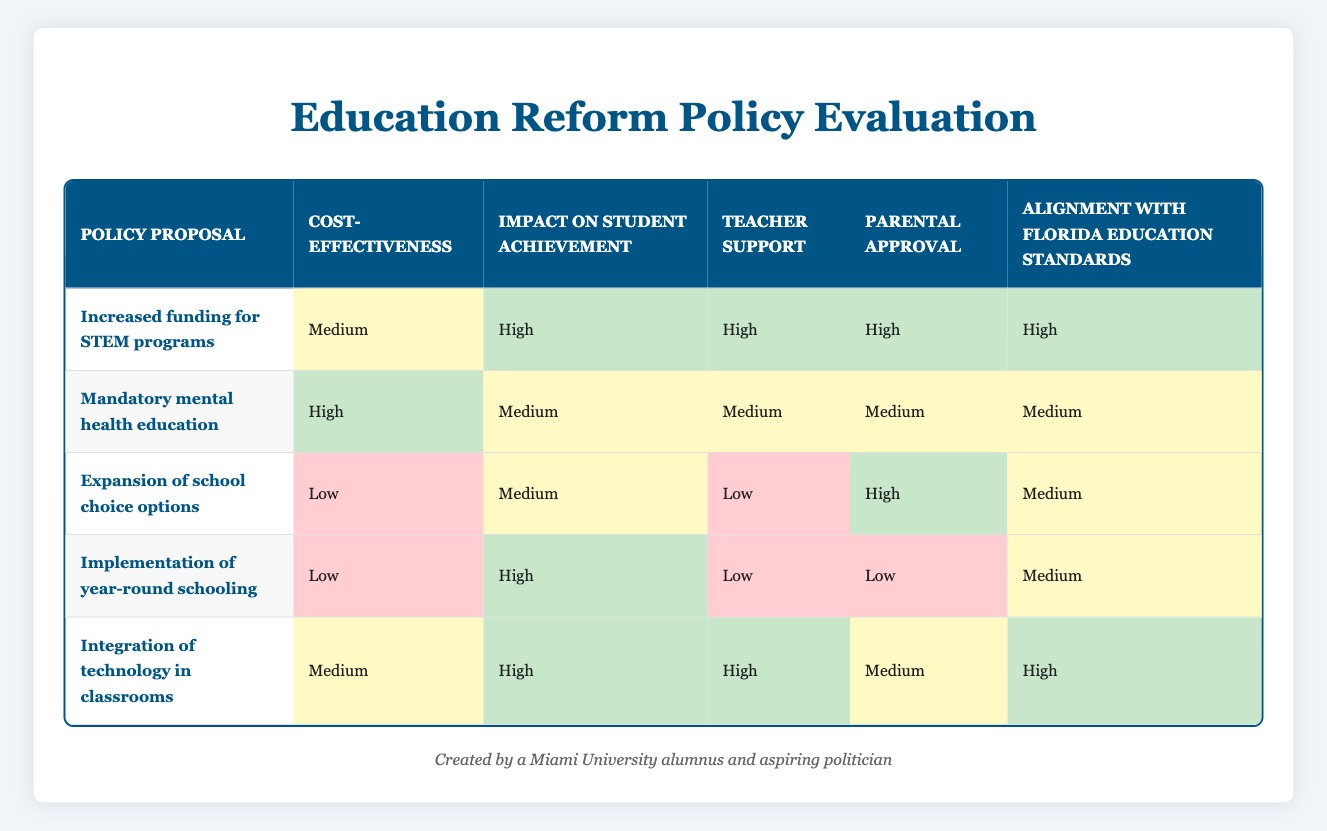What is the cost-effectiveness rating of the proposal for increased funding for STEM programs? The proposal for increased funding for STEM programs has a stated cost-effectiveness rating of "Medium" in the table.
Answer: Medium Which policy proposal received the highest teacher support? The policy proposal "Increased funding for STEM programs" and "Integration of technology in classrooms" both received "High" ratings for teacher support, which is the highest rating in the table.
Answer: Increased funding for STEM programs and Integration of technology in classrooms Are parents generally approving of the implementation of year-round schooling? The table shows that parental approval for the implementation of year-round schooling is rated as "Low." Therefore, parents are not generally approving of this proposal.
Answer: No What is the average impact on student achievement from all policy proposals listed? The ratings for impact on student achievement are High, Medium, Medium, High, and High. To find the average, we can assign values: High=3, Medium=2, Low=1. Thus, (3 + 2 + 2 + 3 + 3) = 13 and since there are 5 proposals, 13/5 = 2.6, which can be rounded to "Medium."
Answer: Medium Does the proposal for integration of technology in classrooms align with Florida education standards? Yes, the proposal for integration of technology in classrooms is rated "High" for alignment with Florida education standards. Thus, it does align well with those standards.
Answer: Yes What policy proposal has the lowest ratings for both cost-effectiveness and teacher support? The proposal "Expansion of school choice options" has the lowest ratings of "Low" for both cost-effectiveness and teacher support when compared to others in the table.
Answer: Expansion of school choice options What are the contrasting aspects of mandatory mental health education in terms of cost-effectiveness and parental approval? Mandatory mental health education has a "High" rating for cost-effectiveness, while its parental approval rating is "Medium." This shows a contrast between high financial viability and average parental support.
Answer: Cost-effectiveness is High; parental approval is Medium Which proposals have a high impact on student achievement but low parental approval? The proposal "Implementation of year-round schooling" is the only one that has a "High" rating for impact on student achievement and a "Low" rating for parental approval. Thus, it stands out as not having parental support despite improving achievement.
Answer: Implementation of year-round schooling 